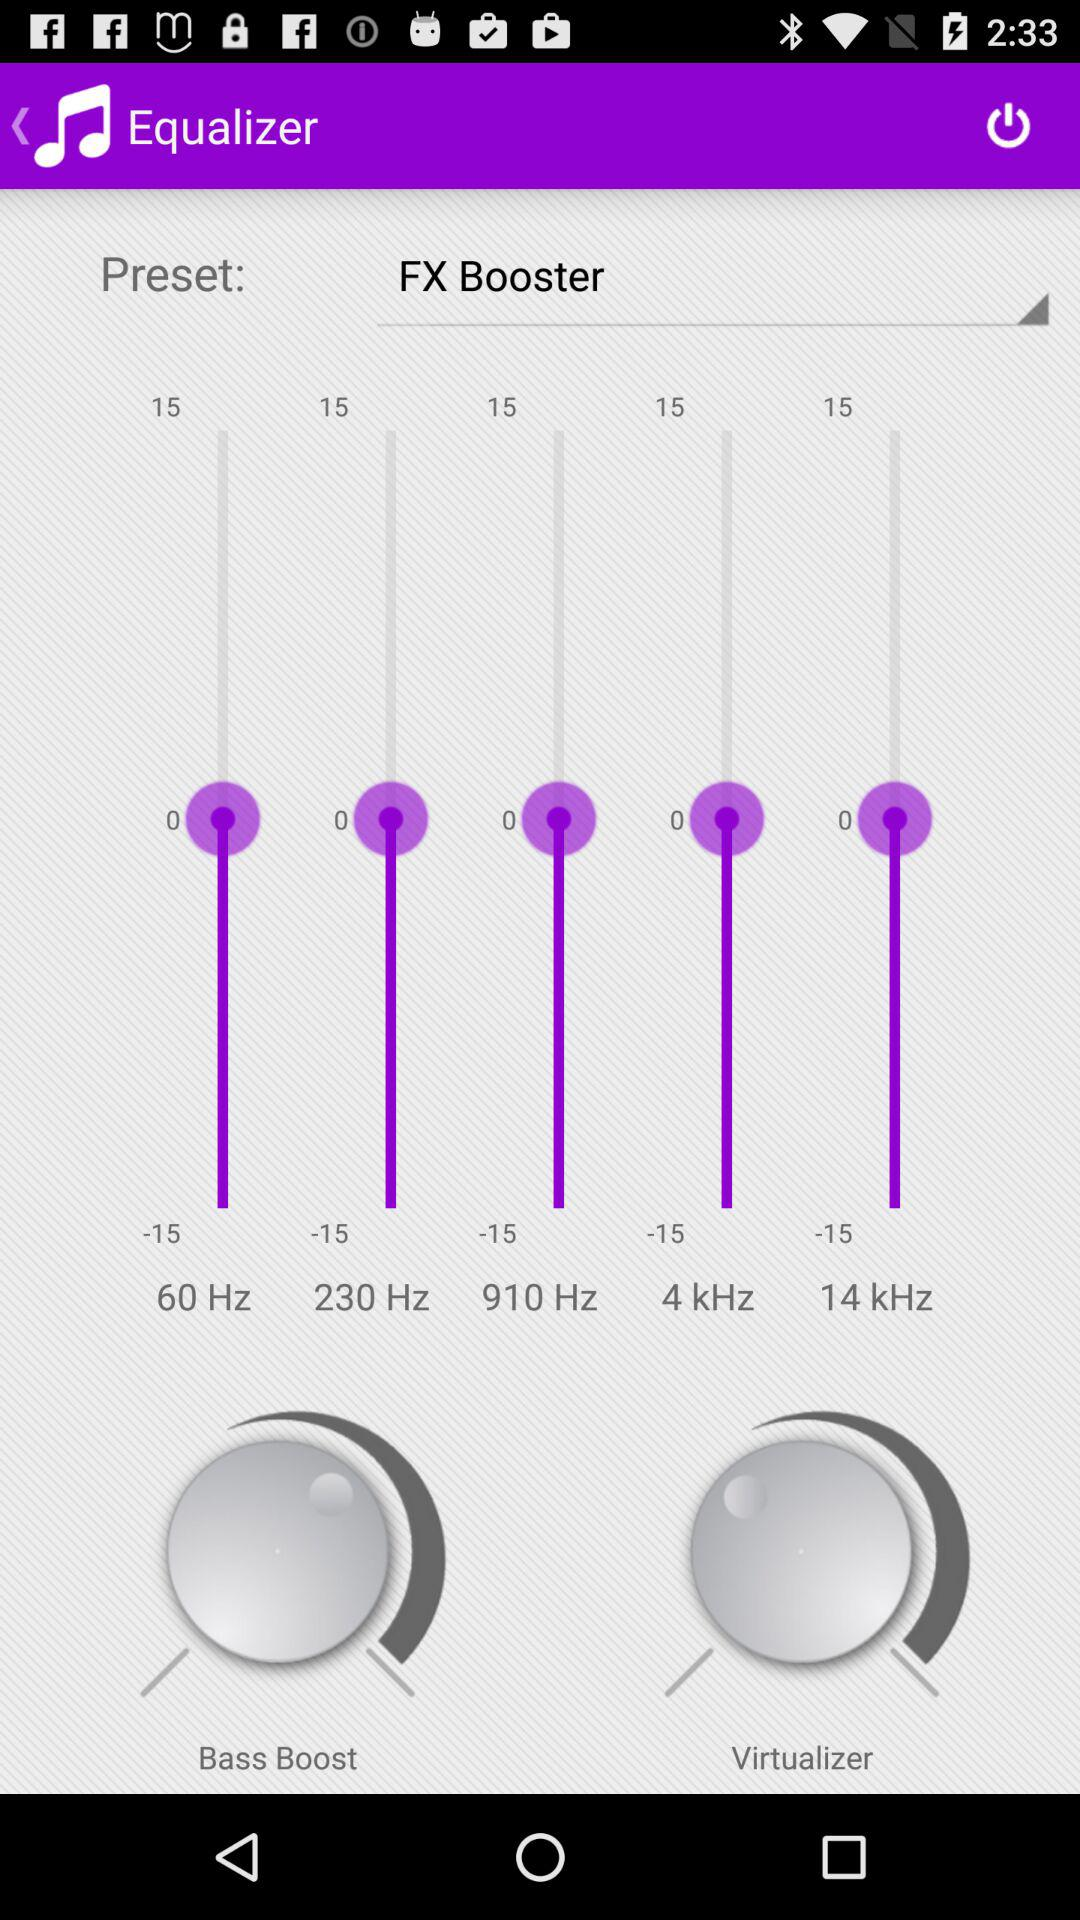Which option has been selected in "Preset"? The selected option is "FX Booster". 